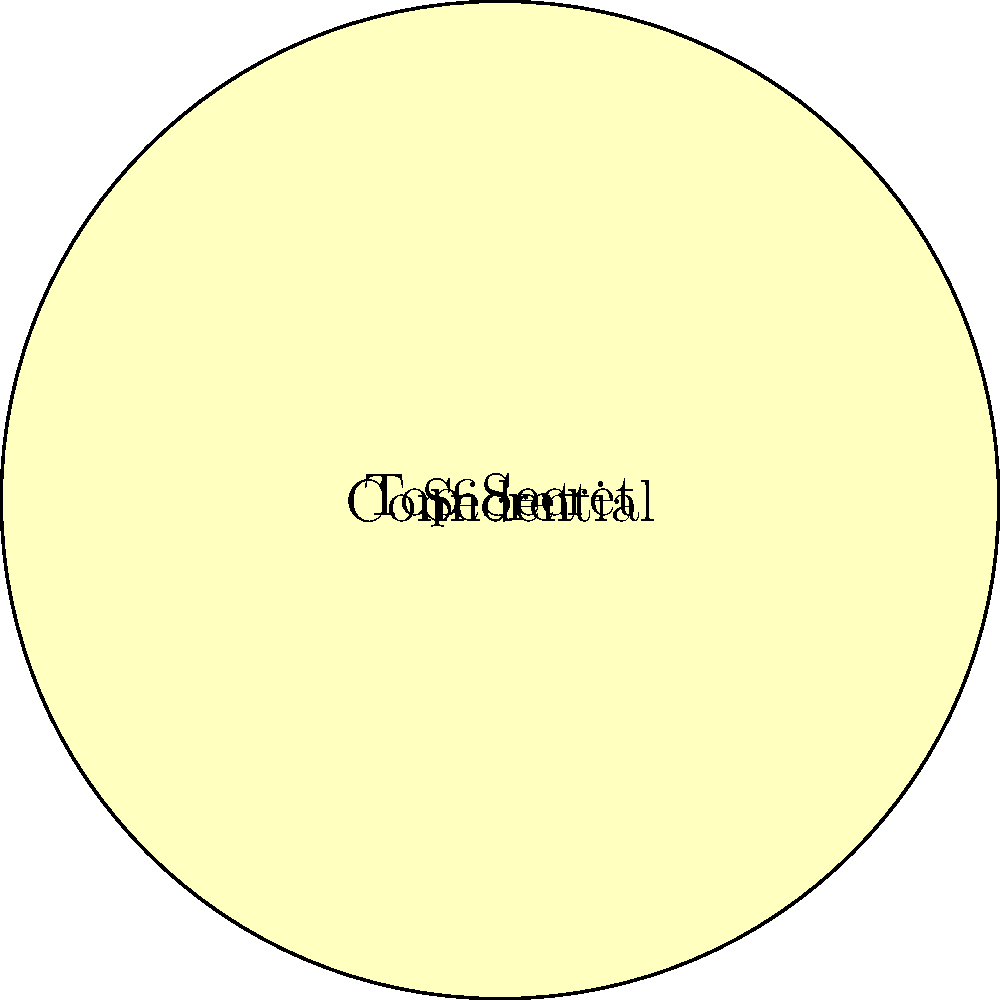Based on the image recognition data shown in the radar chart, which classification level has the highest percentage of documents containing sensitive foreign policy information (represented by category 3)? To determine which classification level has the highest percentage of documents containing sensitive foreign policy information, we need to analyze category 3 across all classification levels:

1. Identify category 3 on the radar chart (right side of the chart).
2. Compare the data points for each classification level:
   - Confidential (inner blue circle): 10%
   - Secret (middle red circle): 20%
   - Top Secret (outer yellow circle): 40%

3. The Top Secret classification has the highest percentage at 40% for category 3.

This indicates that Top Secret documents are most likely to contain sensitive foreign policy information, which aligns with the expectation that higher classification levels would include more critical and sensitive information.
Answer: Top Secret 